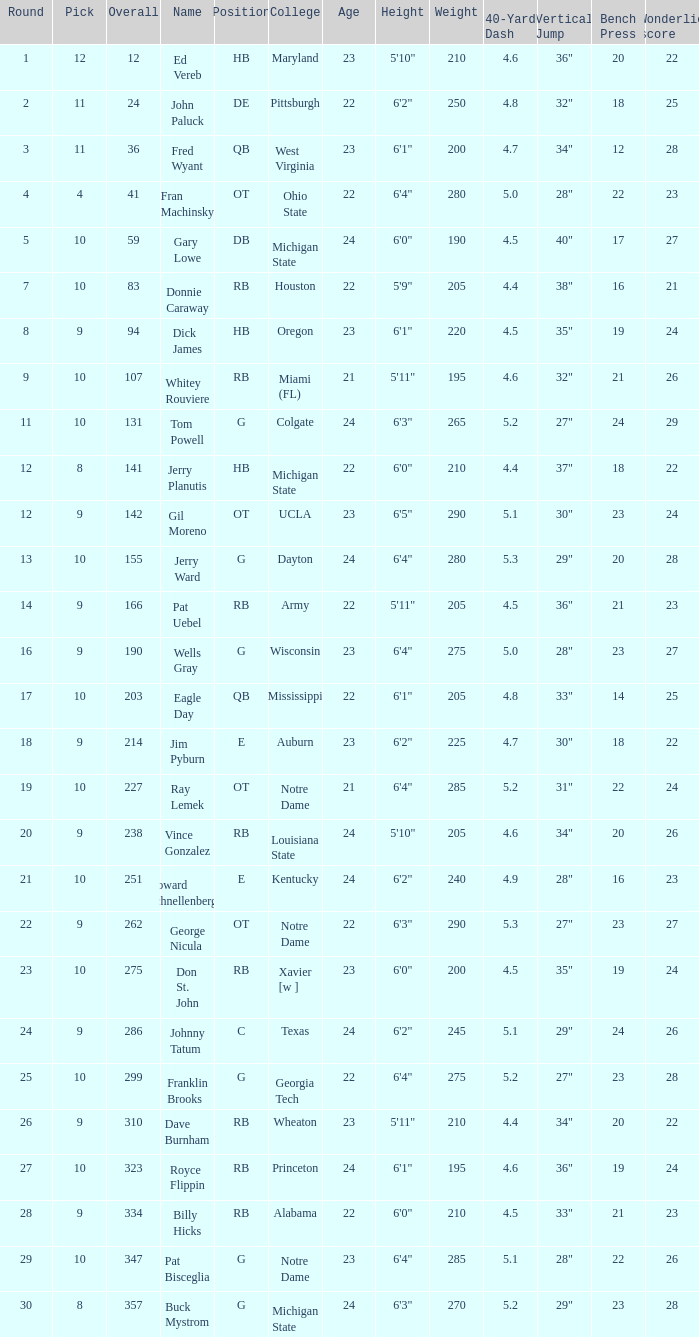What is the total number of overall picks that were after pick 9 and went to Auburn College? 0.0. 